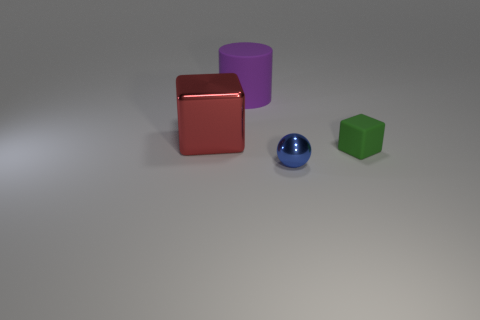Add 1 tiny blue balls. How many objects exist? 5 Subtract all cylinders. How many objects are left? 3 Add 4 metallic balls. How many metallic balls exist? 5 Subtract 1 blue spheres. How many objects are left? 3 Subtract all small green blocks. Subtract all small things. How many objects are left? 1 Add 4 big things. How many big things are left? 6 